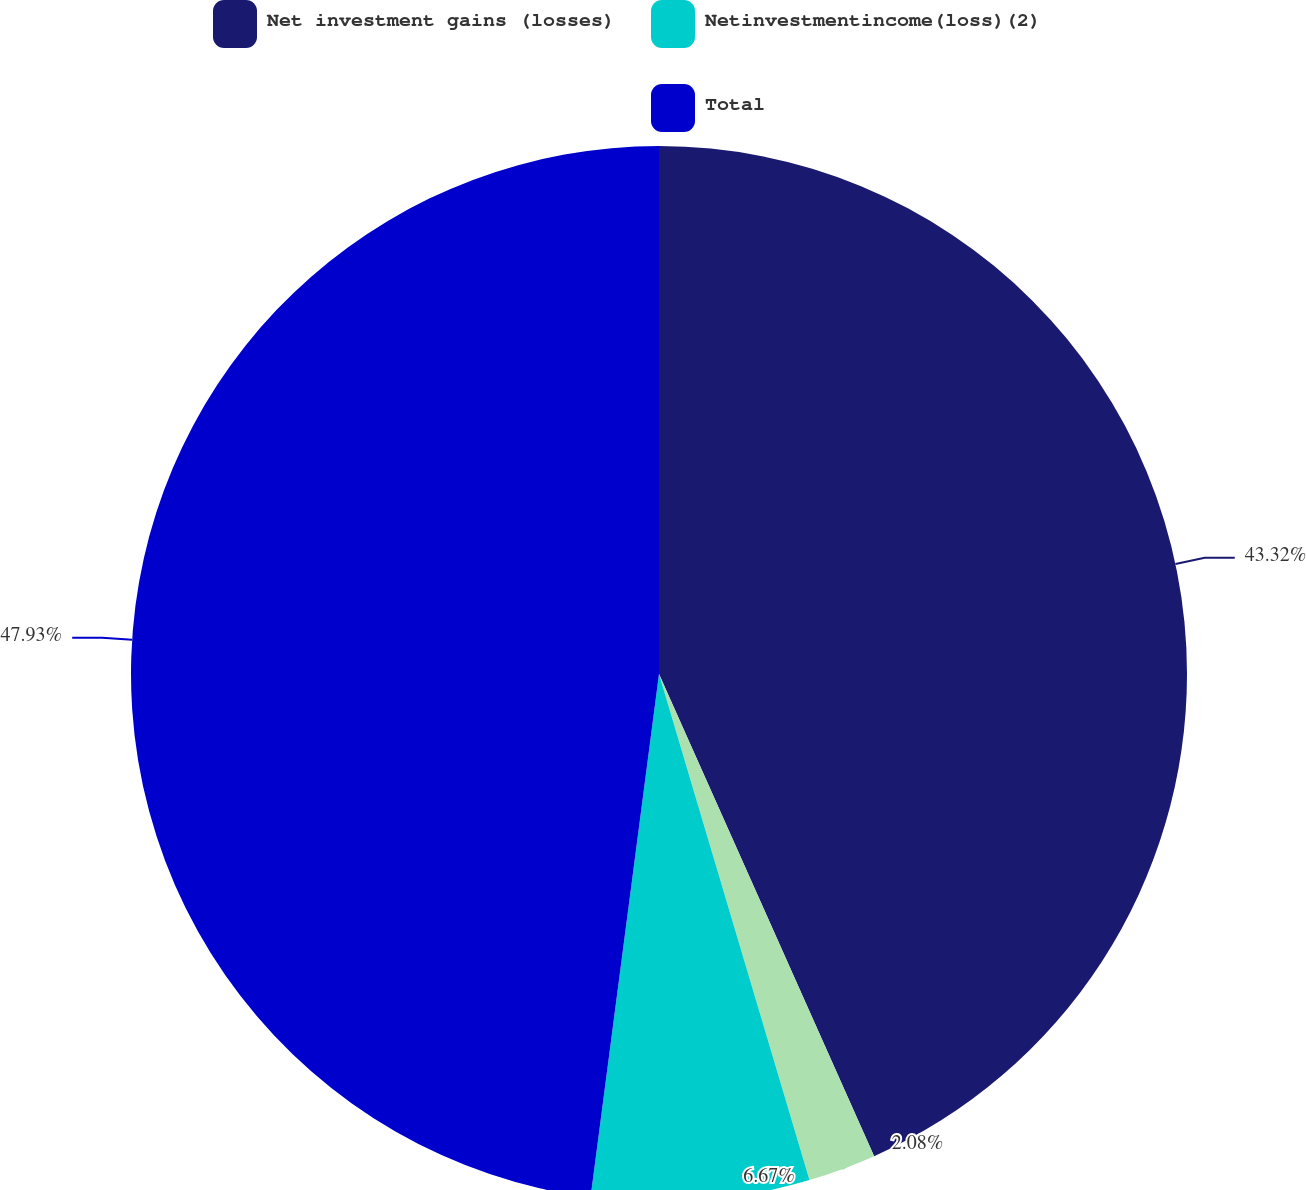Convert chart to OTSL. <chart><loc_0><loc_0><loc_500><loc_500><pie_chart><fcel>Net investment gains (losses)<fcel>Unnamed: 1<fcel>Netinvestmentincome(loss)(2)<fcel>Total<nl><fcel>43.32%<fcel>2.08%<fcel>6.67%<fcel>47.93%<nl></chart> 